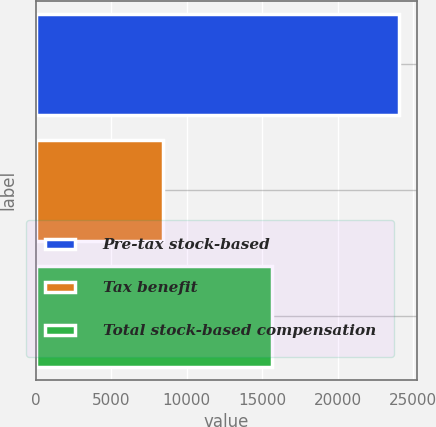<chart> <loc_0><loc_0><loc_500><loc_500><bar_chart><fcel>Pre-tax stock-based<fcel>Tax benefit<fcel>Total stock-based compensation<nl><fcel>24073<fcel>8411<fcel>15662<nl></chart> 